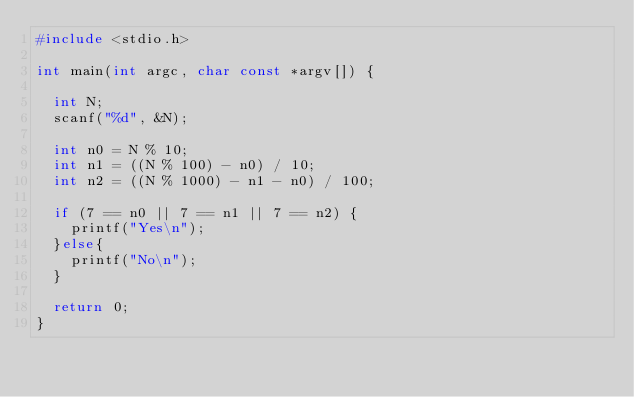Convert code to text. <code><loc_0><loc_0><loc_500><loc_500><_C_>#include <stdio.h>

int main(int argc, char const *argv[]) {

  int N;
  scanf("%d", &N);

  int n0 = N % 10;
  int n1 = ((N % 100) - n0) / 10;
  int n2 = ((N % 1000) - n1 - n0) / 100;

  if (7 == n0 || 7 == n1 || 7 == n2) {
    printf("Yes\n");
  }else{
    printf("No\n");
  }

  return 0;
}
</code> 